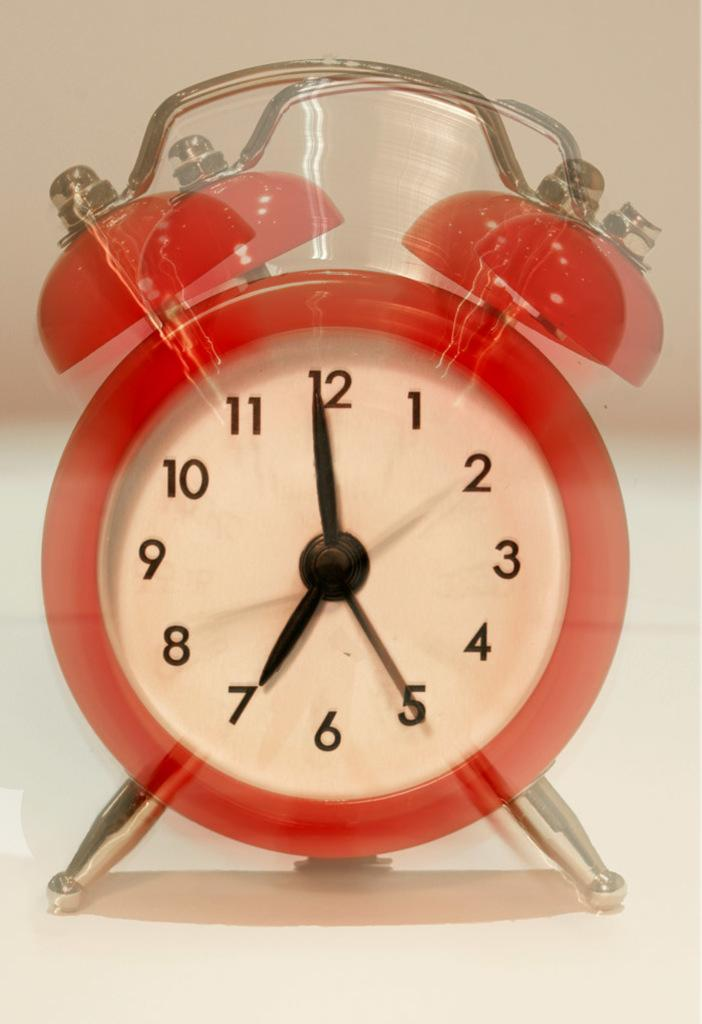<image>
Summarize the visual content of the image. A red, old fashioned alarm clock showing the time of 7:00. 